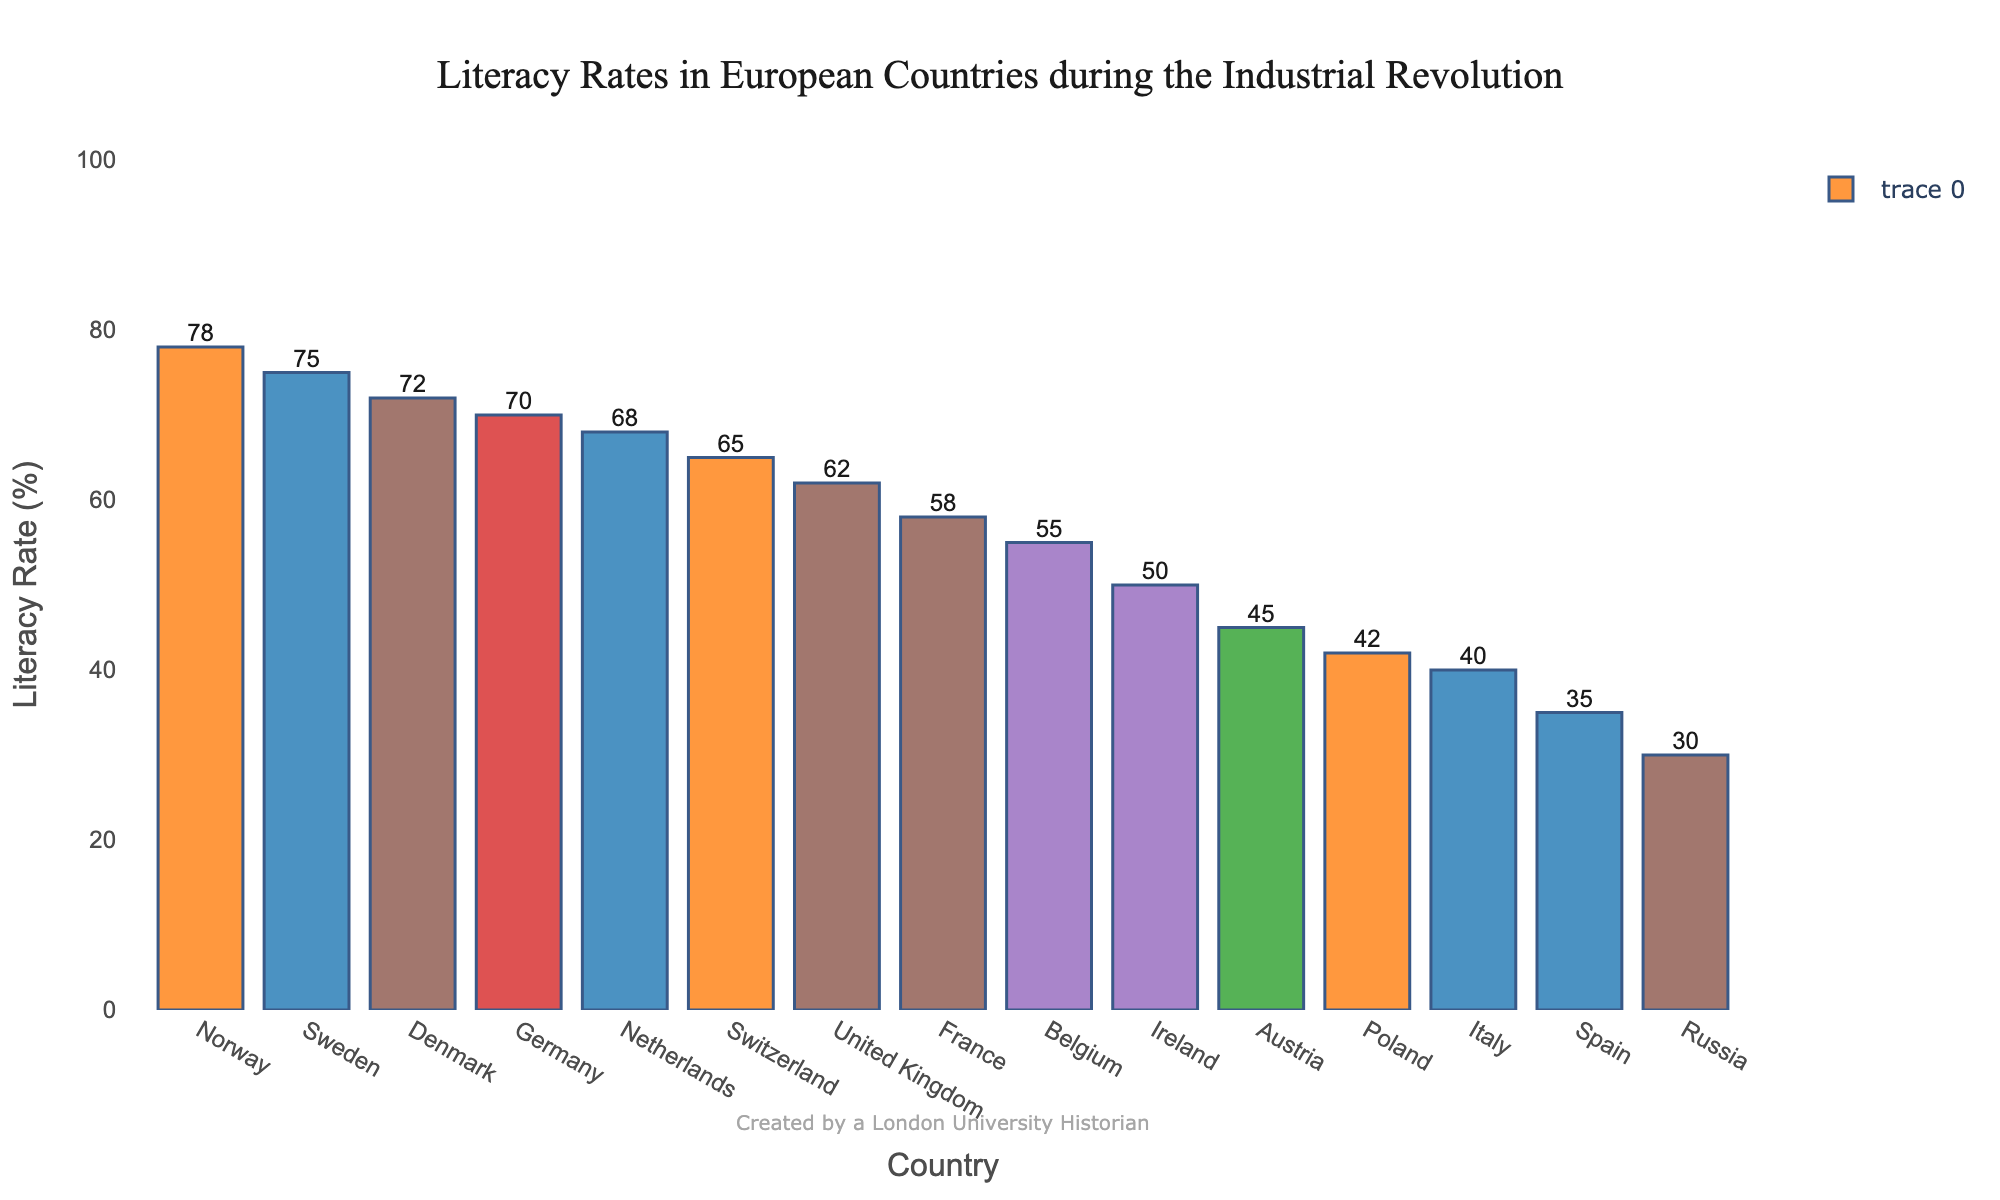Which country has the highest literacy rate? By examining the figure, we can see that Norway has the tallest bar representing a literacy rate of 78%, which is the highest among the listed countries.
Answer: Norway Which two countries have the lowest literacy rates? According to the figure, Russia and Spain have the shortest bars, with literacy rates of 30% and 35%, respectively.
Answer: Russia and Spain How does the literacy rate of Germany compare to that of the United Kingdom? The bar for Germany is slightly higher than the bar for the United Kingdom, indicating that Germany has a higher literacy rate of 70% compared to the United Kingdom's 62%.
Answer: Germany has a higher literacy rate What is the average literacy rate of the top 3 countries? The top 3 countries by literacy rate are Norway (78%), Sweden (75%), and Denmark (72%). Adding these rates gives 78 + 75 + 72 = 225. The average is 225 / 3 = 75%.
Answer: 75% Which country has a literacy rate closest to the median value of all countries listed? To find the median, sort the literacy rates and select the middle value. The sorted rates are 30, 35, 40, 42, 45, 50, 55, 58, 62, 65, 68, 70, 72, 75, 78. The median is 58 (France).
Answer: France What are the total literacy rates of France, Belgium, and Switzerland combined? Adding the literacy rates: France (58%) + Belgium (55%) + Switzerland (65%) = 178.
Answer: 178% Is the literacy rate of Austria greater than, less than, or equal to the average literacy rate of Ireland and Italy? The literacy rates are: Austria (45%), Ireland (50%), and Italy (40%). Average for Ireland and Italy is (50 + 40) / 2 = 45%. Austria's rate (45%) is equal to the average of Ireland and Italy (45%).
Answer: Equal Which countries have literacy rates between 40% and 60%? Based on the figure, the countries with literacy rates within this range are Belgium (55%), France (58%), Austria (45%), Italy (40%), Poland (42%), and Ireland (50%).
Answer: Belgium, France, Austria, Italy, Poland, Ireland How much higher is Denmark's literacy rate compared to Austria's? Denmark has a literacy rate of 72%, while Austria has 45%. The difference is 72 - 45 = 27%.
Answer: 27% Which countries have a higher literacy rate than the United Kingdom but lower than Sweden? The United Kingdom has a literacy rate of 62%, and Sweden has 75%. The countries between these are Germany (70%), Denmark (72%), Netherlands (68%), and Switzerland (65%).
Answer: Germany, Denmark, Netherlands, Switzerland 